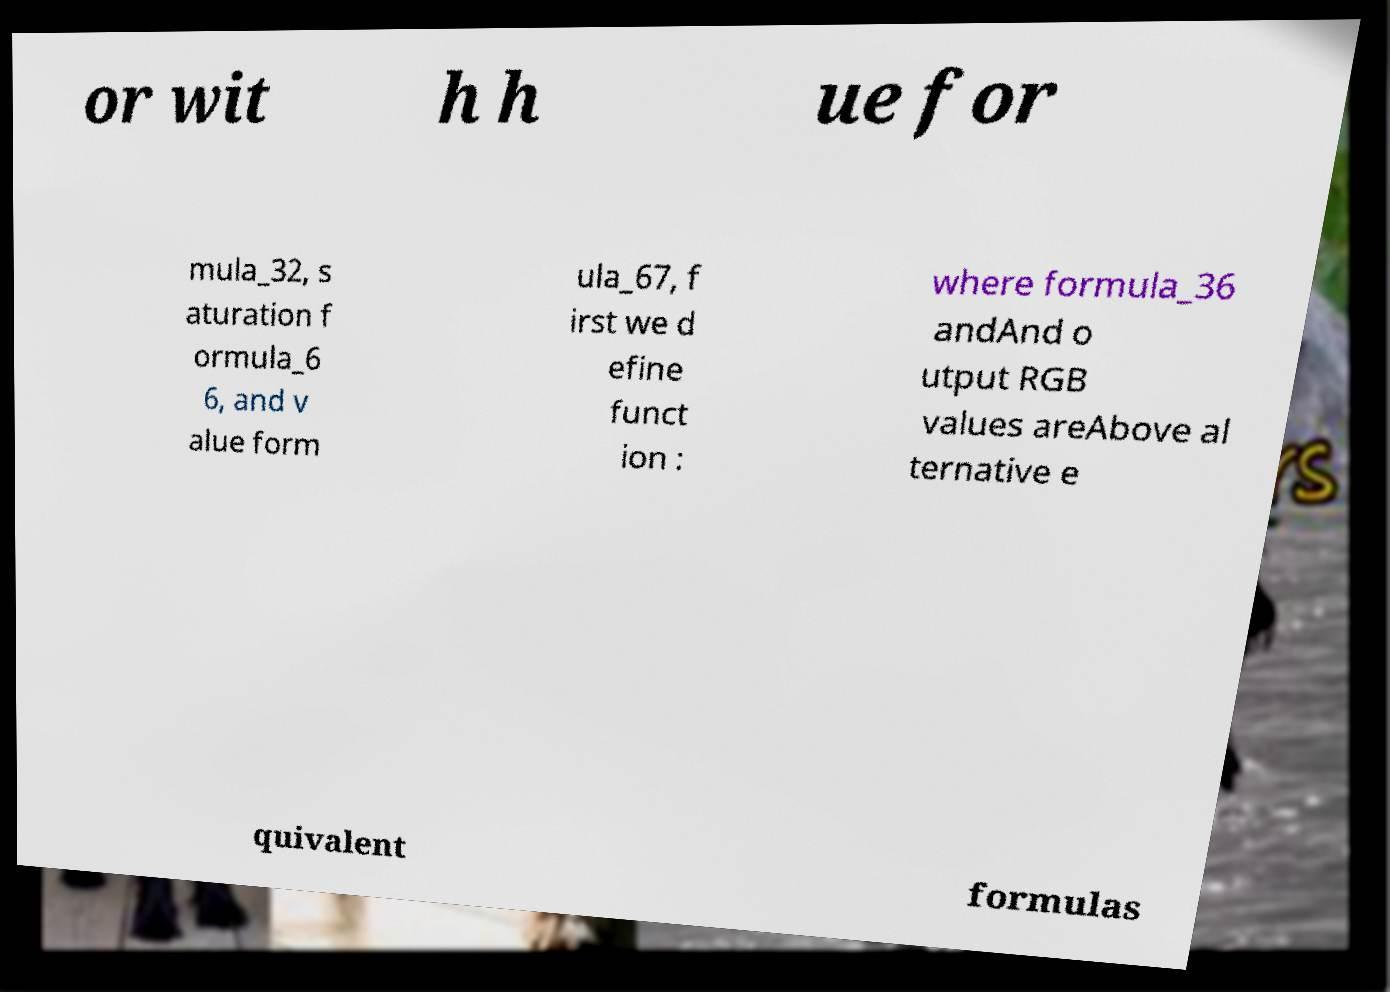Can you accurately transcribe the text from the provided image for me? or wit h h ue for mula_32, s aturation f ormula_6 6, and v alue form ula_67, f irst we d efine funct ion : where formula_36 andAnd o utput RGB values areAbove al ternative e quivalent formulas 